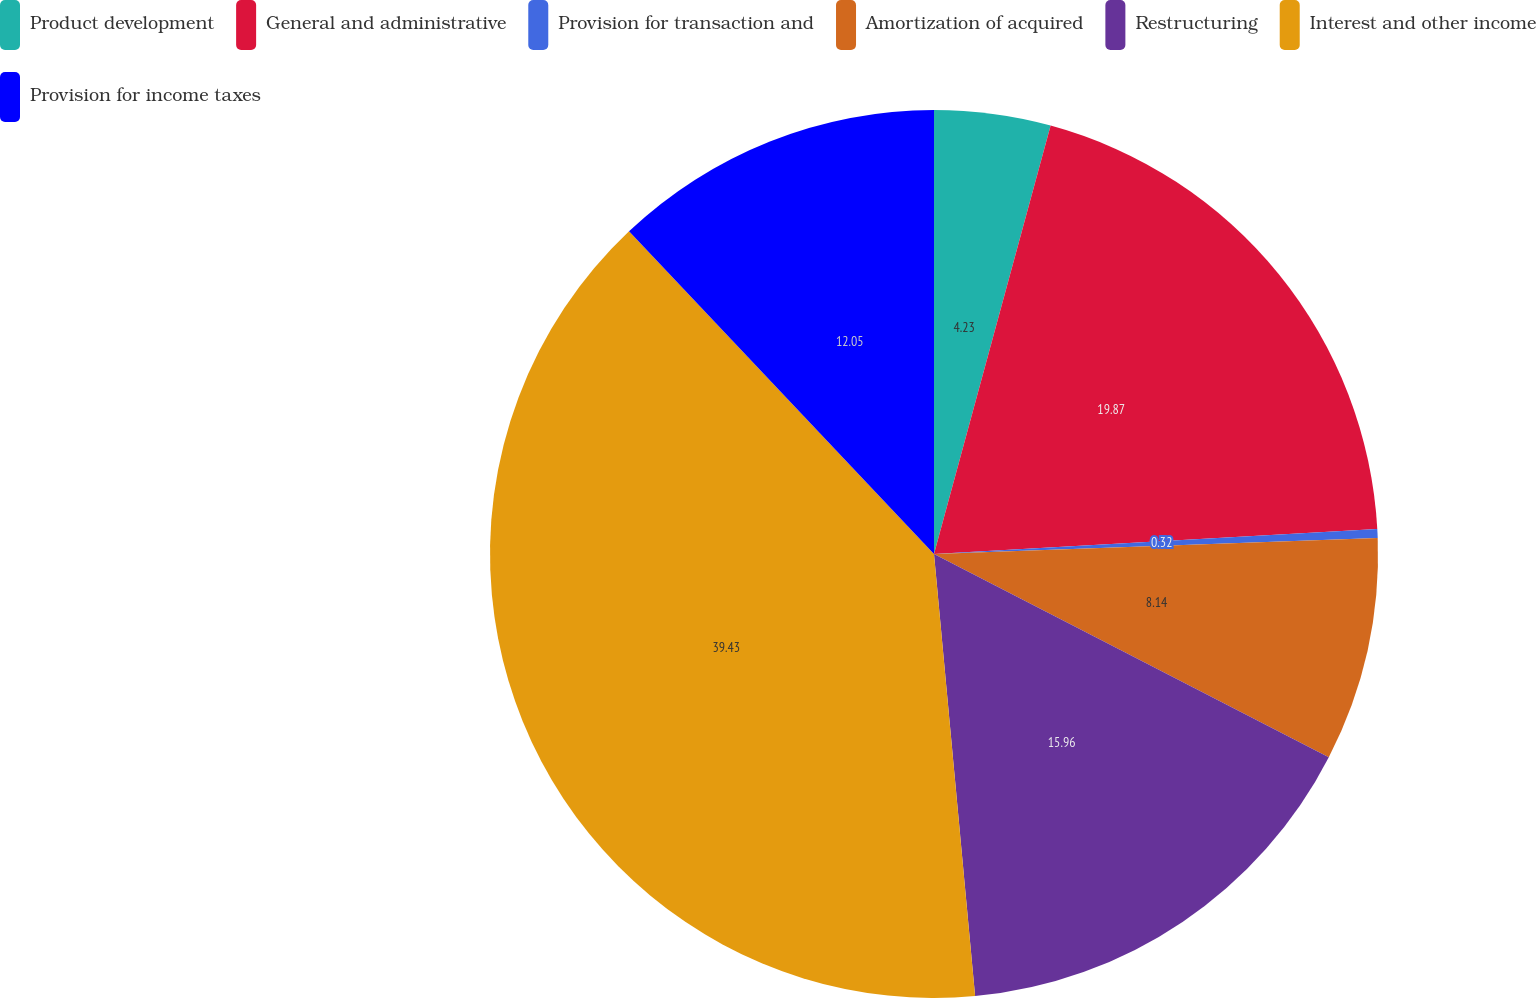Convert chart to OTSL. <chart><loc_0><loc_0><loc_500><loc_500><pie_chart><fcel>Product development<fcel>General and administrative<fcel>Provision for transaction and<fcel>Amortization of acquired<fcel>Restructuring<fcel>Interest and other income<fcel>Provision for income taxes<nl><fcel>4.23%<fcel>19.87%<fcel>0.32%<fcel>8.14%<fcel>15.96%<fcel>39.42%<fcel>12.05%<nl></chart> 